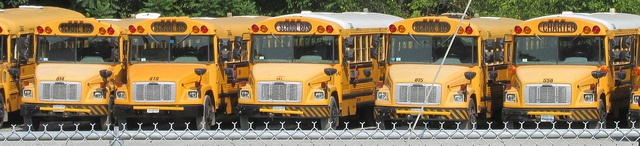Describe the objects in this image and their specific colors. I can see bus in black, gray, olive, and lightgray tones, bus in black, gray, orange, and brown tones, bus in black, gray, orange, and tan tones, bus in black, orange, and gray tones, and bus in black, orange, tan, and gray tones in this image. 